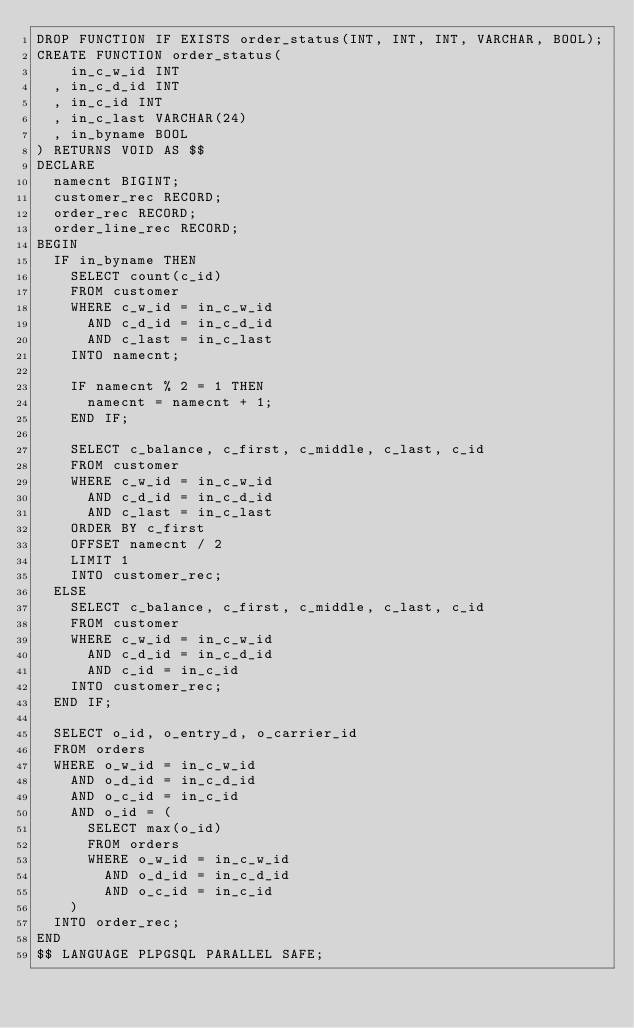Convert code to text. <code><loc_0><loc_0><loc_500><loc_500><_SQL_>DROP FUNCTION IF EXISTS order_status(INT, INT, INT, VARCHAR, BOOL);
CREATE FUNCTION order_status(
    in_c_w_id INT
  , in_c_d_id INT
  , in_c_id INT
  , in_c_last VARCHAR(24)
  , in_byname BOOL
) RETURNS VOID AS $$
DECLARE
  namecnt BIGINT;
  customer_rec RECORD;
  order_rec RECORD;
  order_line_rec RECORD;
BEGIN
  IF in_byname THEN
    SELECT count(c_id)
    FROM customer
    WHERE c_w_id = in_c_w_id
      AND c_d_id = in_c_d_id
      AND c_last = in_c_last
    INTO namecnt;

    IF namecnt % 2 = 1 THEN
      namecnt = namecnt + 1;
    END IF;

    SELECT c_balance, c_first, c_middle, c_last, c_id
    FROM customer
    WHERE c_w_id = in_c_w_id
      AND c_d_id = in_c_d_id
      AND c_last = in_c_last
    ORDER BY c_first
    OFFSET namecnt / 2
    LIMIT 1
    INTO customer_rec;
  ELSE
    SELECT c_balance, c_first, c_middle, c_last, c_id
    FROM customer
    WHERE c_w_id = in_c_w_id
      AND c_d_id = in_c_d_id
      AND c_id = in_c_id
    INTO customer_rec;
  END IF;

  SELECT o_id, o_entry_d, o_carrier_id
  FROM orders
  WHERE o_w_id = in_c_w_id
    AND o_d_id = in_c_d_id
    AND o_c_id = in_c_id
    AND o_id = (
      SELECT max(o_id)
      FROM orders
      WHERE o_w_id = in_c_w_id
        AND o_d_id = in_c_d_id
        AND o_c_id = in_c_id
    )
  INTO order_rec;
END
$$ LANGUAGE PLPGSQL PARALLEL SAFE;
</code> 